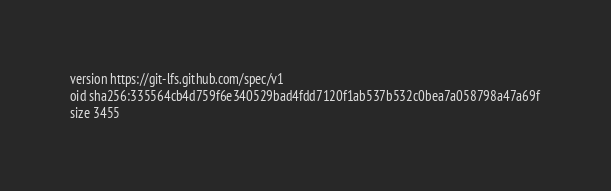Convert code to text. <code><loc_0><loc_0><loc_500><loc_500><_YAML_>version https://git-lfs.github.com/spec/v1
oid sha256:335564cb4d759f6e340529bad4fdd7120f1ab537b532c0bea7a058798a47a69f
size 3455
</code> 